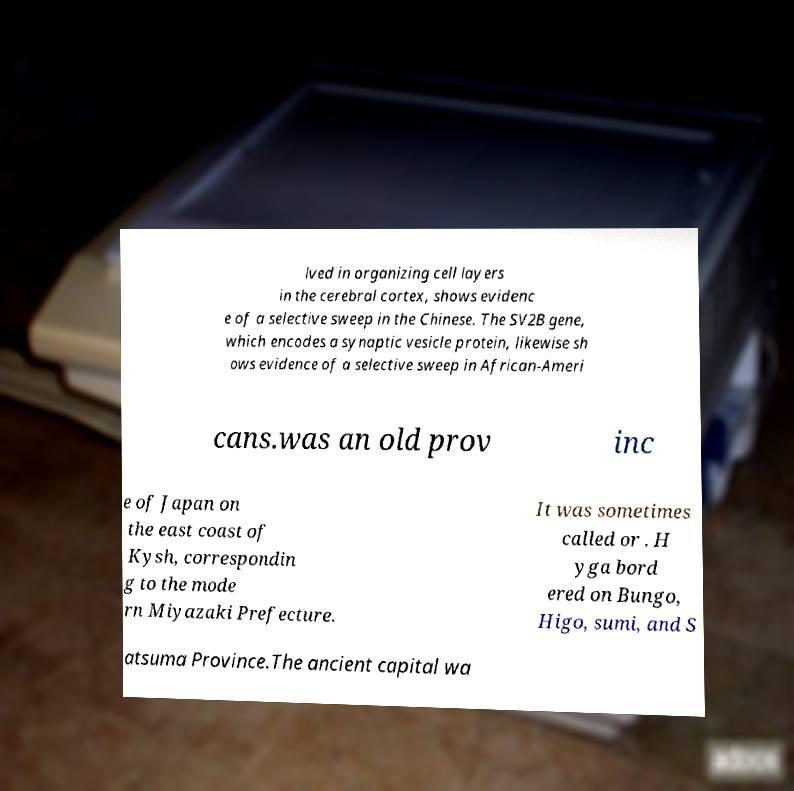There's text embedded in this image that I need extracted. Can you transcribe it verbatim? lved in organizing cell layers in the cerebral cortex, shows evidenc e of a selective sweep in the Chinese. The SV2B gene, which encodes a synaptic vesicle protein, likewise sh ows evidence of a selective sweep in African-Ameri cans.was an old prov inc e of Japan on the east coast of Kysh, correspondin g to the mode rn Miyazaki Prefecture. It was sometimes called or . H yga bord ered on Bungo, Higo, sumi, and S atsuma Province.The ancient capital wa 